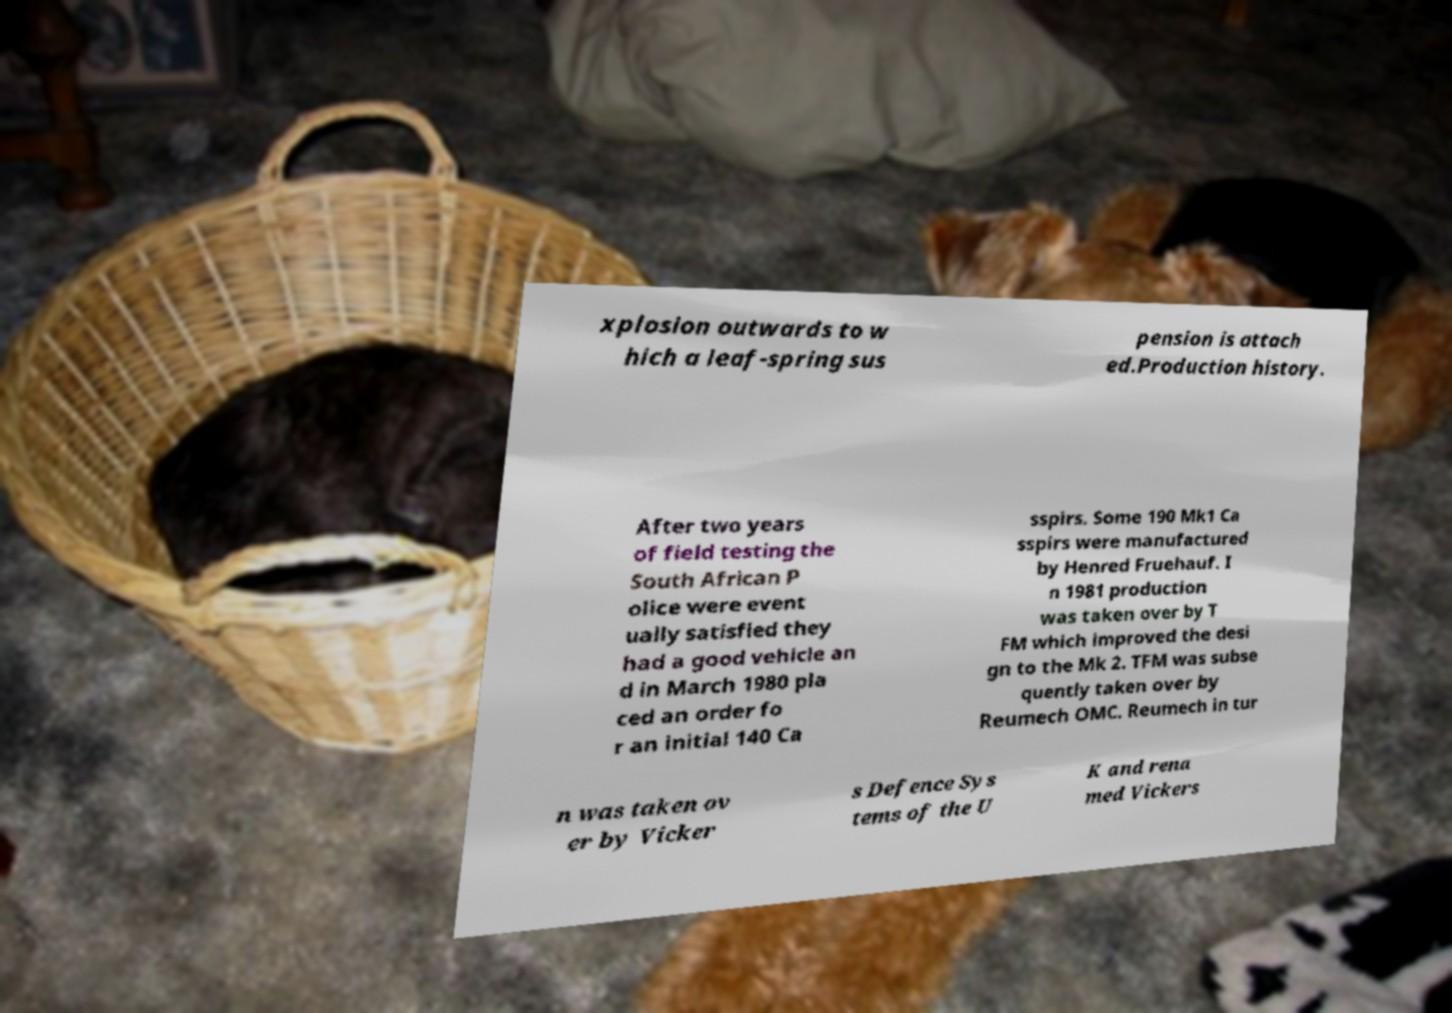Please identify and transcribe the text found in this image. xplosion outwards to w hich a leaf-spring sus pension is attach ed.Production history. After two years of field testing the South African P olice were event ually satisfied they had a good vehicle an d in March 1980 pla ced an order fo r an initial 140 Ca sspirs. Some 190 Mk1 Ca sspirs were manufactured by Henred Fruehauf. I n 1981 production was taken over by T FM which improved the desi gn to the Mk 2. TFM was subse quently taken over by Reumech OMC. Reumech in tur n was taken ov er by Vicker s Defence Sys tems of the U K and rena med Vickers 